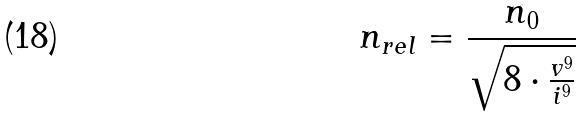Convert formula to latex. <formula><loc_0><loc_0><loc_500><loc_500>n _ { r e l } = \frac { n _ { 0 } } { \sqrt { 8 \cdot \frac { v ^ { 9 } } { i ^ { 9 } } } }</formula> 